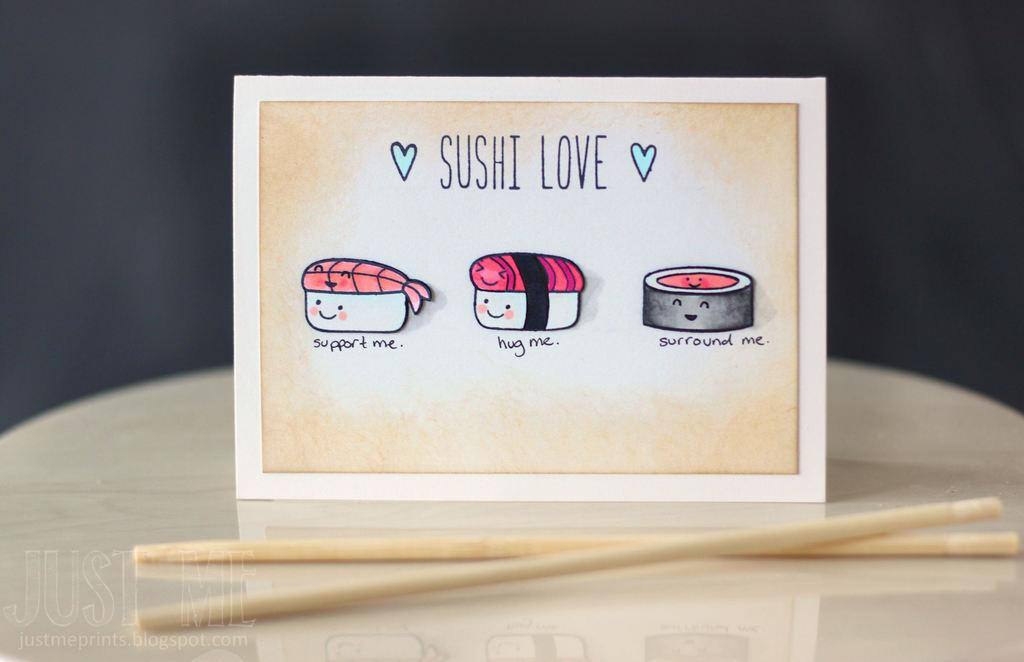What is the main object in the image? There is a table in the image. What is placed on the table? There is a greeting card on the table. Are there any other objects on the table? Yes, there are two sticks on the table. What type of gun is visible on the table in the image? There is no gun present in the image; only a table, a greeting card, and two sticks are visible. 